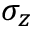<formula> <loc_0><loc_0><loc_500><loc_500>\sigma _ { z }</formula> 